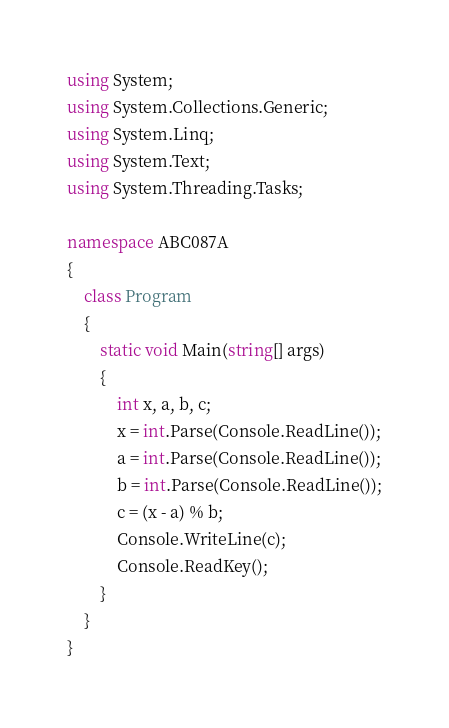Convert code to text. <code><loc_0><loc_0><loc_500><loc_500><_C#_>using System;
using System.Collections.Generic;
using System.Linq;
using System.Text;
using System.Threading.Tasks;

namespace ABC087A
{
    class Program
    {
        static void Main(string[] args)
        { 
            int x, a, b, c;
            x = int.Parse(Console.ReadLine());
            a = int.Parse(Console.ReadLine());
            b = int.Parse(Console.ReadLine());
            c = (x - a) % b;
            Console.WriteLine(c);
            Console.ReadKey();
        }
    }
}
</code> 